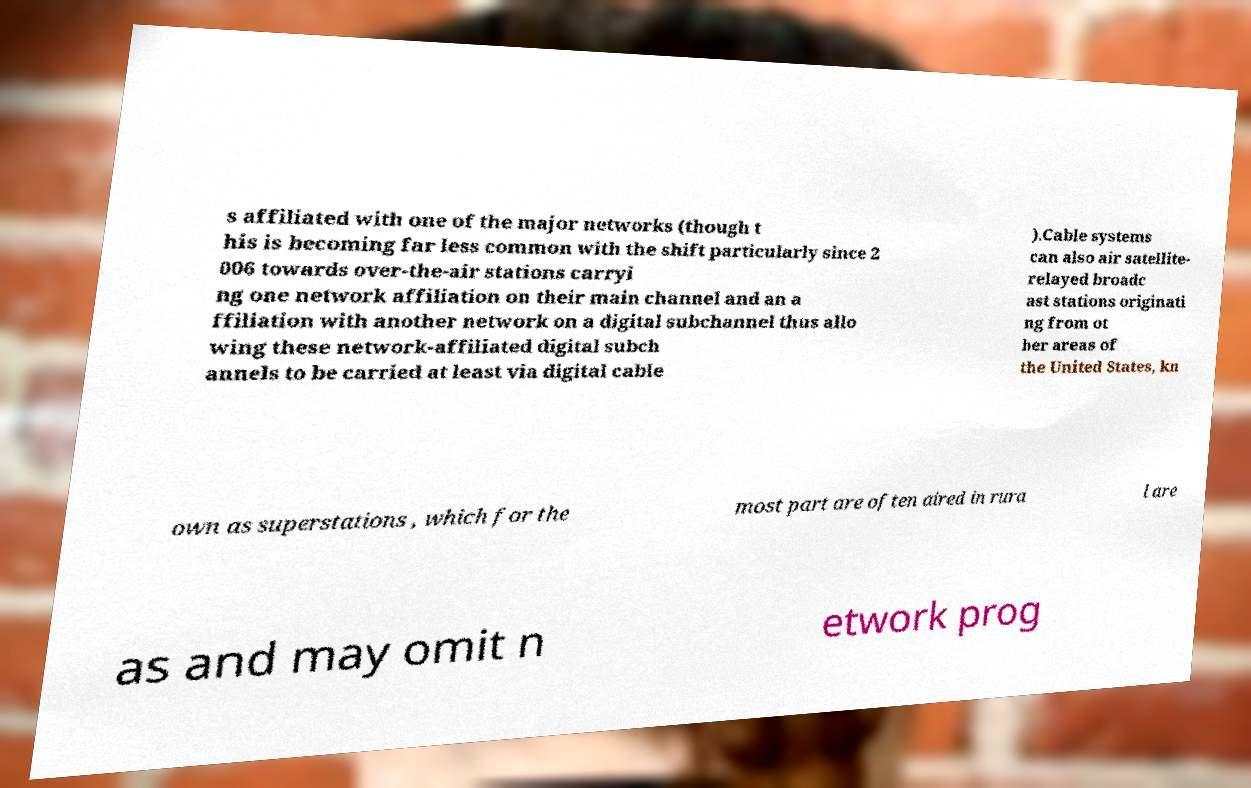There's text embedded in this image that I need extracted. Can you transcribe it verbatim? s affiliated with one of the major networks (though t his is becoming far less common with the shift particularly since 2 006 towards over-the-air stations carryi ng one network affiliation on their main channel and an a ffiliation with another network on a digital subchannel thus allo wing these network-affiliated digital subch annels to be carried at least via digital cable ).Cable systems can also air satellite- relayed broadc ast stations originati ng from ot her areas of the United States, kn own as superstations , which for the most part are often aired in rura l are as and may omit n etwork prog 